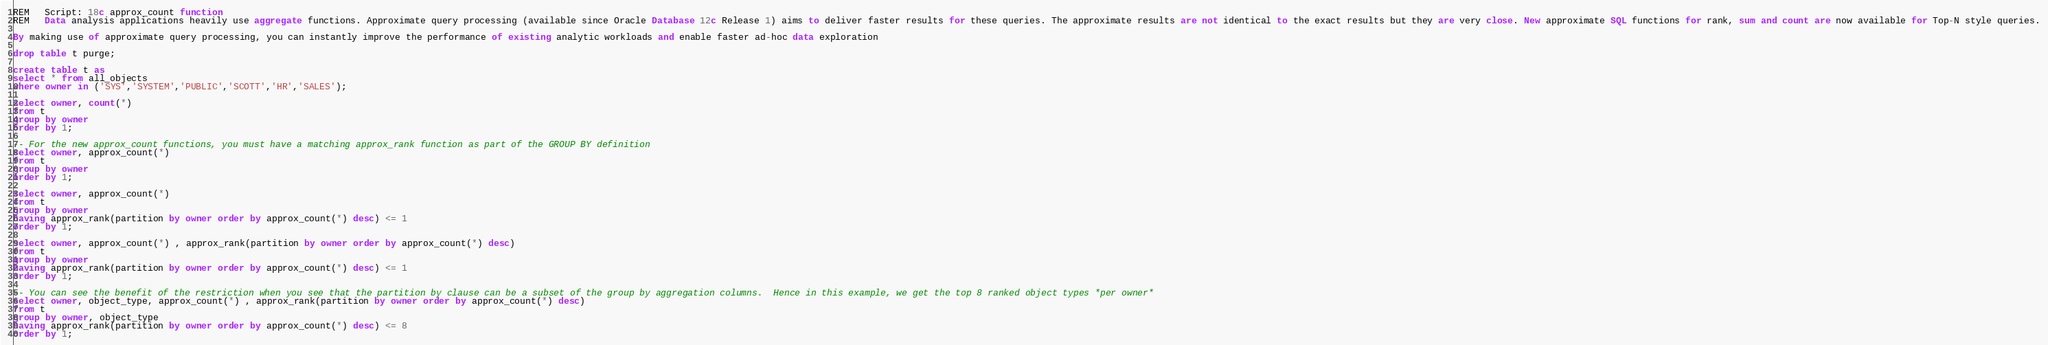Convert code to text. <code><loc_0><loc_0><loc_500><loc_500><_SQL_>REM   Script: 18c approx_count function
REM   Data analysis applications heavily use aggregate functions. Approximate query processing (available since Oracle Database 12c Release 1) aims to deliver faster results for these queries. The approximate results are not identical to the exact results but they are very close. New approximate SQL functions for rank, sum and count are now available for Top-N style queries.

By making use of approximate query processing, you can instantly improve the performance of existing analytic workloads and enable faster ad-hoc data exploration

drop table t purge;

create table t as  
select * from all_objects 
where owner in ('SYS','SYSTEM','PUBLIC','SCOTT','HR','SALES');

select owner, count(*)  
from t 
group by owner 
order by 1;

-- For the new approx_count functions, you must have a matching approx_rank function as part of the GROUP BY definition
select owner, approx_count(*)  
from t 
group by owner 
order by 1;

select owner, approx_count(*)  
from t 
group by owner 
having approx_rank(partition by owner order by approx_count(*) desc) <= 1 
order by 1;

select owner, approx_count(*) , approx_rank(partition by owner order by approx_count(*) desc) 
from t 
group by owner 
having approx_rank(partition by owner order by approx_count(*) desc) <= 1 
order by 1;

-- You can see the benefit of the restriction when you see that the partition by clause can be a subset of the group by aggregation columns.  Hence in this example, we get the top 8 ranked object types *per owner*
select owner, object_type, approx_count(*) , approx_rank(partition by owner order by approx_count(*) desc) 
from t 
group by owner, object_type 
having approx_rank(partition by owner order by approx_count(*) desc) <= 8 
order by 1;

</code> 